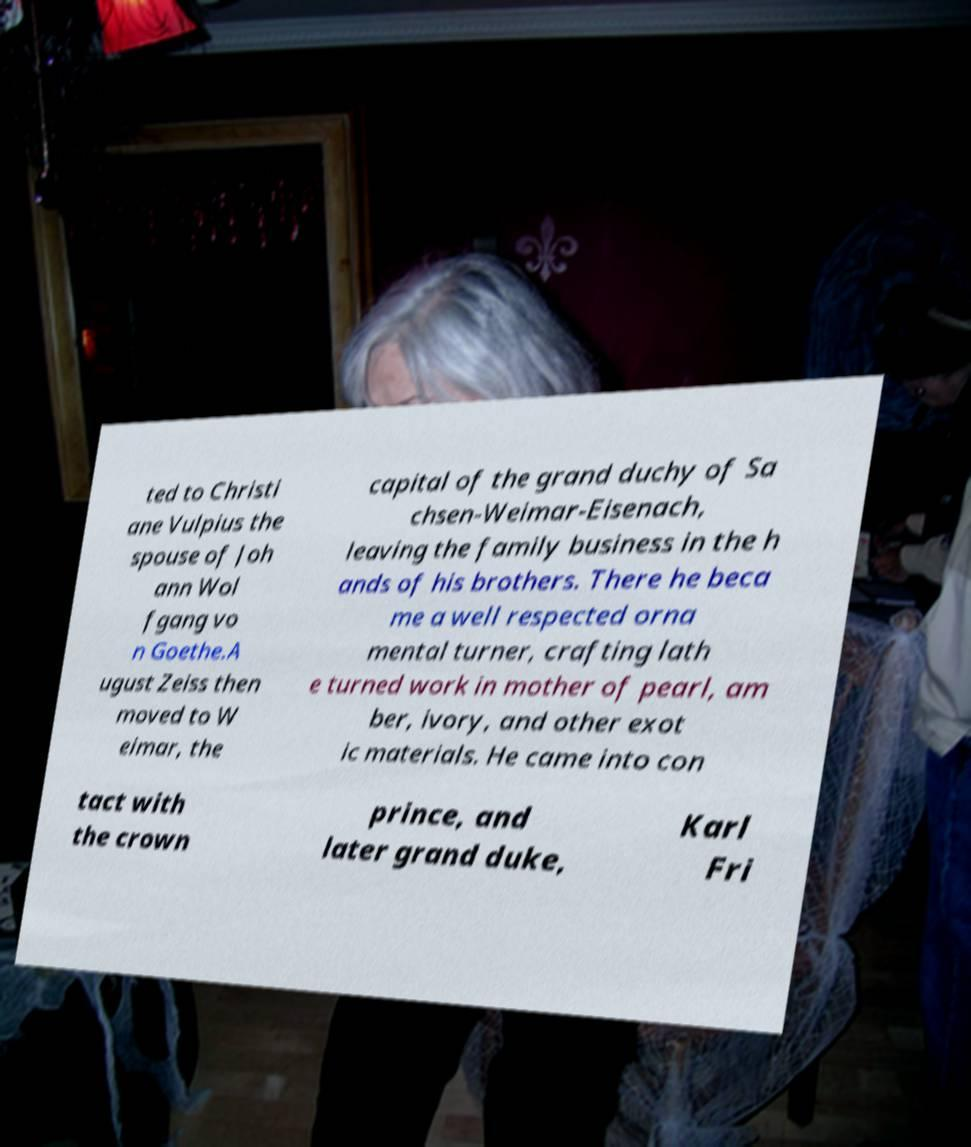I need the written content from this picture converted into text. Can you do that? ted to Christi ane Vulpius the spouse of Joh ann Wol fgang vo n Goethe.A ugust Zeiss then moved to W eimar, the capital of the grand duchy of Sa chsen-Weimar-Eisenach, leaving the family business in the h ands of his brothers. There he beca me a well respected orna mental turner, crafting lath e turned work in mother of pearl, am ber, ivory, and other exot ic materials. He came into con tact with the crown prince, and later grand duke, Karl Fri 